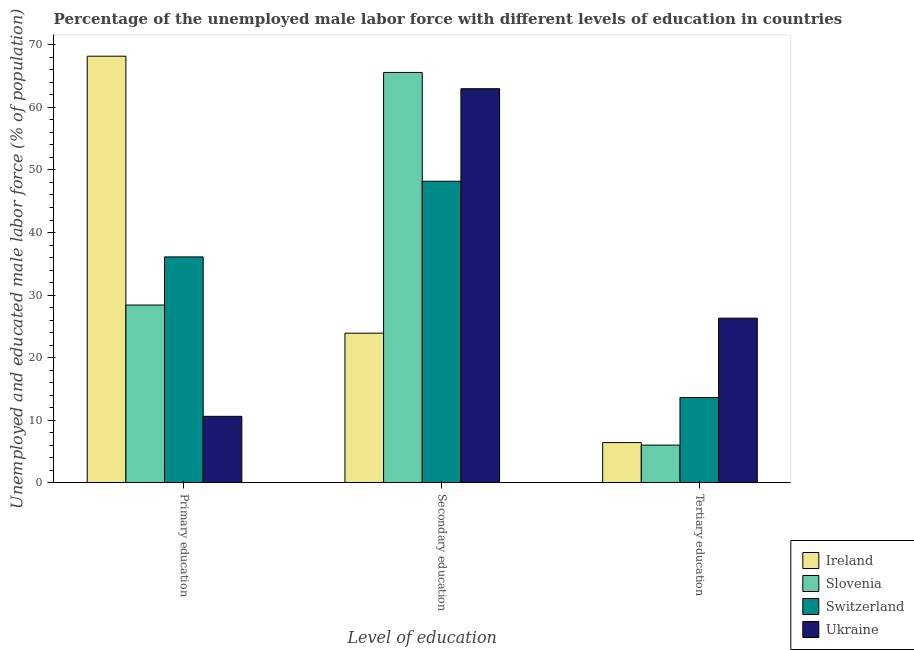Are the number of bars per tick equal to the number of legend labels?
Your answer should be very brief. Yes. Are the number of bars on each tick of the X-axis equal?
Offer a very short reply. Yes. How many bars are there on the 1st tick from the left?
Your response must be concise. 4. How many bars are there on the 2nd tick from the right?
Ensure brevity in your answer.  4. What is the label of the 2nd group of bars from the left?
Offer a terse response. Secondary education. What is the percentage of male labor force who received primary education in Ireland?
Provide a succinct answer. 68.2. Across all countries, what is the maximum percentage of male labor force who received tertiary education?
Provide a short and direct response. 26.3. Across all countries, what is the minimum percentage of male labor force who received primary education?
Offer a very short reply. 10.6. In which country was the percentage of male labor force who received primary education maximum?
Your response must be concise. Ireland. In which country was the percentage of male labor force who received primary education minimum?
Keep it short and to the point. Ukraine. What is the total percentage of male labor force who received secondary education in the graph?
Give a very brief answer. 200.7. What is the difference between the percentage of male labor force who received secondary education in Ireland and that in Ukraine?
Offer a terse response. -39.1. What is the difference between the percentage of male labor force who received tertiary education in Switzerland and the percentage of male labor force who received secondary education in Ireland?
Ensure brevity in your answer.  -10.3. What is the average percentage of male labor force who received secondary education per country?
Ensure brevity in your answer.  50.17. What is the difference between the percentage of male labor force who received secondary education and percentage of male labor force who received primary education in Slovenia?
Your answer should be compact. 37.2. In how many countries, is the percentage of male labor force who received tertiary education greater than 68 %?
Offer a very short reply. 0. What is the ratio of the percentage of male labor force who received secondary education in Switzerland to that in Slovenia?
Offer a terse response. 0.73. What is the difference between the highest and the second highest percentage of male labor force who received tertiary education?
Provide a succinct answer. 12.7. What is the difference between the highest and the lowest percentage of male labor force who received tertiary education?
Keep it short and to the point. 20.3. In how many countries, is the percentage of male labor force who received primary education greater than the average percentage of male labor force who received primary education taken over all countries?
Keep it short and to the point. 2. What does the 3rd bar from the left in Primary education represents?
Ensure brevity in your answer.  Switzerland. What does the 1st bar from the right in Primary education represents?
Make the answer very short. Ukraine. Is it the case that in every country, the sum of the percentage of male labor force who received primary education and percentage of male labor force who received secondary education is greater than the percentage of male labor force who received tertiary education?
Your response must be concise. Yes. How many bars are there?
Your answer should be compact. 12. How many countries are there in the graph?
Your answer should be very brief. 4. What is the difference between two consecutive major ticks on the Y-axis?
Offer a terse response. 10. Are the values on the major ticks of Y-axis written in scientific E-notation?
Give a very brief answer. No. Does the graph contain any zero values?
Make the answer very short. No. Where does the legend appear in the graph?
Offer a very short reply. Bottom right. How many legend labels are there?
Keep it short and to the point. 4. How are the legend labels stacked?
Give a very brief answer. Vertical. What is the title of the graph?
Offer a terse response. Percentage of the unemployed male labor force with different levels of education in countries. What is the label or title of the X-axis?
Give a very brief answer. Level of education. What is the label or title of the Y-axis?
Provide a short and direct response. Unemployed and educated male labor force (% of population). What is the Unemployed and educated male labor force (% of population) of Ireland in Primary education?
Provide a succinct answer. 68.2. What is the Unemployed and educated male labor force (% of population) in Slovenia in Primary education?
Your response must be concise. 28.4. What is the Unemployed and educated male labor force (% of population) of Switzerland in Primary education?
Your answer should be very brief. 36.1. What is the Unemployed and educated male labor force (% of population) in Ukraine in Primary education?
Your response must be concise. 10.6. What is the Unemployed and educated male labor force (% of population) of Ireland in Secondary education?
Offer a very short reply. 23.9. What is the Unemployed and educated male labor force (% of population) in Slovenia in Secondary education?
Keep it short and to the point. 65.6. What is the Unemployed and educated male labor force (% of population) in Switzerland in Secondary education?
Your response must be concise. 48.2. What is the Unemployed and educated male labor force (% of population) of Ukraine in Secondary education?
Your response must be concise. 63. What is the Unemployed and educated male labor force (% of population) in Ireland in Tertiary education?
Your response must be concise. 6.4. What is the Unemployed and educated male labor force (% of population) of Switzerland in Tertiary education?
Your response must be concise. 13.6. What is the Unemployed and educated male labor force (% of population) of Ukraine in Tertiary education?
Make the answer very short. 26.3. Across all Level of education, what is the maximum Unemployed and educated male labor force (% of population) in Ireland?
Your answer should be very brief. 68.2. Across all Level of education, what is the maximum Unemployed and educated male labor force (% of population) in Slovenia?
Ensure brevity in your answer.  65.6. Across all Level of education, what is the maximum Unemployed and educated male labor force (% of population) of Switzerland?
Your response must be concise. 48.2. Across all Level of education, what is the maximum Unemployed and educated male labor force (% of population) of Ukraine?
Keep it short and to the point. 63. Across all Level of education, what is the minimum Unemployed and educated male labor force (% of population) of Ireland?
Ensure brevity in your answer.  6.4. Across all Level of education, what is the minimum Unemployed and educated male labor force (% of population) of Slovenia?
Offer a terse response. 6. Across all Level of education, what is the minimum Unemployed and educated male labor force (% of population) of Switzerland?
Give a very brief answer. 13.6. Across all Level of education, what is the minimum Unemployed and educated male labor force (% of population) in Ukraine?
Keep it short and to the point. 10.6. What is the total Unemployed and educated male labor force (% of population) of Ireland in the graph?
Make the answer very short. 98.5. What is the total Unemployed and educated male labor force (% of population) in Slovenia in the graph?
Provide a short and direct response. 100. What is the total Unemployed and educated male labor force (% of population) in Switzerland in the graph?
Give a very brief answer. 97.9. What is the total Unemployed and educated male labor force (% of population) of Ukraine in the graph?
Ensure brevity in your answer.  99.9. What is the difference between the Unemployed and educated male labor force (% of population) of Ireland in Primary education and that in Secondary education?
Make the answer very short. 44.3. What is the difference between the Unemployed and educated male labor force (% of population) of Slovenia in Primary education and that in Secondary education?
Make the answer very short. -37.2. What is the difference between the Unemployed and educated male labor force (% of population) in Ukraine in Primary education and that in Secondary education?
Provide a short and direct response. -52.4. What is the difference between the Unemployed and educated male labor force (% of population) in Ireland in Primary education and that in Tertiary education?
Make the answer very short. 61.8. What is the difference between the Unemployed and educated male labor force (% of population) in Slovenia in Primary education and that in Tertiary education?
Make the answer very short. 22.4. What is the difference between the Unemployed and educated male labor force (% of population) in Switzerland in Primary education and that in Tertiary education?
Make the answer very short. 22.5. What is the difference between the Unemployed and educated male labor force (% of population) of Ukraine in Primary education and that in Tertiary education?
Give a very brief answer. -15.7. What is the difference between the Unemployed and educated male labor force (% of population) of Slovenia in Secondary education and that in Tertiary education?
Offer a terse response. 59.6. What is the difference between the Unemployed and educated male labor force (% of population) in Switzerland in Secondary education and that in Tertiary education?
Your response must be concise. 34.6. What is the difference between the Unemployed and educated male labor force (% of population) in Ukraine in Secondary education and that in Tertiary education?
Provide a succinct answer. 36.7. What is the difference between the Unemployed and educated male labor force (% of population) in Ireland in Primary education and the Unemployed and educated male labor force (% of population) in Switzerland in Secondary education?
Keep it short and to the point. 20. What is the difference between the Unemployed and educated male labor force (% of population) in Ireland in Primary education and the Unemployed and educated male labor force (% of population) in Ukraine in Secondary education?
Offer a very short reply. 5.2. What is the difference between the Unemployed and educated male labor force (% of population) of Slovenia in Primary education and the Unemployed and educated male labor force (% of population) of Switzerland in Secondary education?
Your answer should be very brief. -19.8. What is the difference between the Unemployed and educated male labor force (% of population) of Slovenia in Primary education and the Unemployed and educated male labor force (% of population) of Ukraine in Secondary education?
Provide a succinct answer. -34.6. What is the difference between the Unemployed and educated male labor force (% of population) in Switzerland in Primary education and the Unemployed and educated male labor force (% of population) in Ukraine in Secondary education?
Your response must be concise. -26.9. What is the difference between the Unemployed and educated male labor force (% of population) in Ireland in Primary education and the Unemployed and educated male labor force (% of population) in Slovenia in Tertiary education?
Offer a terse response. 62.2. What is the difference between the Unemployed and educated male labor force (% of population) of Ireland in Primary education and the Unemployed and educated male labor force (% of population) of Switzerland in Tertiary education?
Your answer should be very brief. 54.6. What is the difference between the Unemployed and educated male labor force (% of population) in Ireland in Primary education and the Unemployed and educated male labor force (% of population) in Ukraine in Tertiary education?
Offer a very short reply. 41.9. What is the difference between the Unemployed and educated male labor force (% of population) of Slovenia in Primary education and the Unemployed and educated male labor force (% of population) of Ukraine in Tertiary education?
Your answer should be very brief. 2.1. What is the difference between the Unemployed and educated male labor force (% of population) of Ireland in Secondary education and the Unemployed and educated male labor force (% of population) of Switzerland in Tertiary education?
Your response must be concise. 10.3. What is the difference between the Unemployed and educated male labor force (% of population) in Slovenia in Secondary education and the Unemployed and educated male labor force (% of population) in Ukraine in Tertiary education?
Make the answer very short. 39.3. What is the difference between the Unemployed and educated male labor force (% of population) of Switzerland in Secondary education and the Unemployed and educated male labor force (% of population) of Ukraine in Tertiary education?
Your answer should be compact. 21.9. What is the average Unemployed and educated male labor force (% of population) in Ireland per Level of education?
Provide a succinct answer. 32.83. What is the average Unemployed and educated male labor force (% of population) of Slovenia per Level of education?
Your answer should be very brief. 33.33. What is the average Unemployed and educated male labor force (% of population) of Switzerland per Level of education?
Give a very brief answer. 32.63. What is the average Unemployed and educated male labor force (% of population) of Ukraine per Level of education?
Give a very brief answer. 33.3. What is the difference between the Unemployed and educated male labor force (% of population) of Ireland and Unemployed and educated male labor force (% of population) of Slovenia in Primary education?
Your response must be concise. 39.8. What is the difference between the Unemployed and educated male labor force (% of population) of Ireland and Unemployed and educated male labor force (% of population) of Switzerland in Primary education?
Ensure brevity in your answer.  32.1. What is the difference between the Unemployed and educated male labor force (% of population) in Ireland and Unemployed and educated male labor force (% of population) in Ukraine in Primary education?
Ensure brevity in your answer.  57.6. What is the difference between the Unemployed and educated male labor force (% of population) of Switzerland and Unemployed and educated male labor force (% of population) of Ukraine in Primary education?
Provide a short and direct response. 25.5. What is the difference between the Unemployed and educated male labor force (% of population) in Ireland and Unemployed and educated male labor force (% of population) in Slovenia in Secondary education?
Keep it short and to the point. -41.7. What is the difference between the Unemployed and educated male labor force (% of population) of Ireland and Unemployed and educated male labor force (% of population) of Switzerland in Secondary education?
Provide a succinct answer. -24.3. What is the difference between the Unemployed and educated male labor force (% of population) of Ireland and Unemployed and educated male labor force (% of population) of Ukraine in Secondary education?
Offer a very short reply. -39.1. What is the difference between the Unemployed and educated male labor force (% of population) of Slovenia and Unemployed and educated male labor force (% of population) of Switzerland in Secondary education?
Your response must be concise. 17.4. What is the difference between the Unemployed and educated male labor force (% of population) of Slovenia and Unemployed and educated male labor force (% of population) of Ukraine in Secondary education?
Your answer should be very brief. 2.6. What is the difference between the Unemployed and educated male labor force (% of population) of Switzerland and Unemployed and educated male labor force (% of population) of Ukraine in Secondary education?
Provide a short and direct response. -14.8. What is the difference between the Unemployed and educated male labor force (% of population) of Ireland and Unemployed and educated male labor force (% of population) of Switzerland in Tertiary education?
Ensure brevity in your answer.  -7.2. What is the difference between the Unemployed and educated male labor force (% of population) of Ireland and Unemployed and educated male labor force (% of population) of Ukraine in Tertiary education?
Make the answer very short. -19.9. What is the difference between the Unemployed and educated male labor force (% of population) in Slovenia and Unemployed and educated male labor force (% of population) in Switzerland in Tertiary education?
Provide a short and direct response. -7.6. What is the difference between the Unemployed and educated male labor force (% of population) in Slovenia and Unemployed and educated male labor force (% of population) in Ukraine in Tertiary education?
Provide a short and direct response. -20.3. What is the difference between the Unemployed and educated male labor force (% of population) of Switzerland and Unemployed and educated male labor force (% of population) of Ukraine in Tertiary education?
Ensure brevity in your answer.  -12.7. What is the ratio of the Unemployed and educated male labor force (% of population) of Ireland in Primary education to that in Secondary education?
Provide a succinct answer. 2.85. What is the ratio of the Unemployed and educated male labor force (% of population) of Slovenia in Primary education to that in Secondary education?
Make the answer very short. 0.43. What is the ratio of the Unemployed and educated male labor force (% of population) in Switzerland in Primary education to that in Secondary education?
Keep it short and to the point. 0.75. What is the ratio of the Unemployed and educated male labor force (% of population) in Ukraine in Primary education to that in Secondary education?
Make the answer very short. 0.17. What is the ratio of the Unemployed and educated male labor force (% of population) in Ireland in Primary education to that in Tertiary education?
Provide a short and direct response. 10.66. What is the ratio of the Unemployed and educated male labor force (% of population) of Slovenia in Primary education to that in Tertiary education?
Ensure brevity in your answer.  4.73. What is the ratio of the Unemployed and educated male labor force (% of population) in Switzerland in Primary education to that in Tertiary education?
Ensure brevity in your answer.  2.65. What is the ratio of the Unemployed and educated male labor force (% of population) of Ukraine in Primary education to that in Tertiary education?
Provide a short and direct response. 0.4. What is the ratio of the Unemployed and educated male labor force (% of population) in Ireland in Secondary education to that in Tertiary education?
Offer a very short reply. 3.73. What is the ratio of the Unemployed and educated male labor force (% of population) of Slovenia in Secondary education to that in Tertiary education?
Offer a terse response. 10.93. What is the ratio of the Unemployed and educated male labor force (% of population) in Switzerland in Secondary education to that in Tertiary education?
Make the answer very short. 3.54. What is the ratio of the Unemployed and educated male labor force (% of population) of Ukraine in Secondary education to that in Tertiary education?
Offer a terse response. 2.4. What is the difference between the highest and the second highest Unemployed and educated male labor force (% of population) in Ireland?
Your answer should be compact. 44.3. What is the difference between the highest and the second highest Unemployed and educated male labor force (% of population) in Slovenia?
Offer a terse response. 37.2. What is the difference between the highest and the second highest Unemployed and educated male labor force (% of population) in Switzerland?
Keep it short and to the point. 12.1. What is the difference between the highest and the second highest Unemployed and educated male labor force (% of population) of Ukraine?
Provide a succinct answer. 36.7. What is the difference between the highest and the lowest Unemployed and educated male labor force (% of population) of Ireland?
Offer a terse response. 61.8. What is the difference between the highest and the lowest Unemployed and educated male labor force (% of population) of Slovenia?
Offer a very short reply. 59.6. What is the difference between the highest and the lowest Unemployed and educated male labor force (% of population) in Switzerland?
Make the answer very short. 34.6. What is the difference between the highest and the lowest Unemployed and educated male labor force (% of population) in Ukraine?
Offer a very short reply. 52.4. 